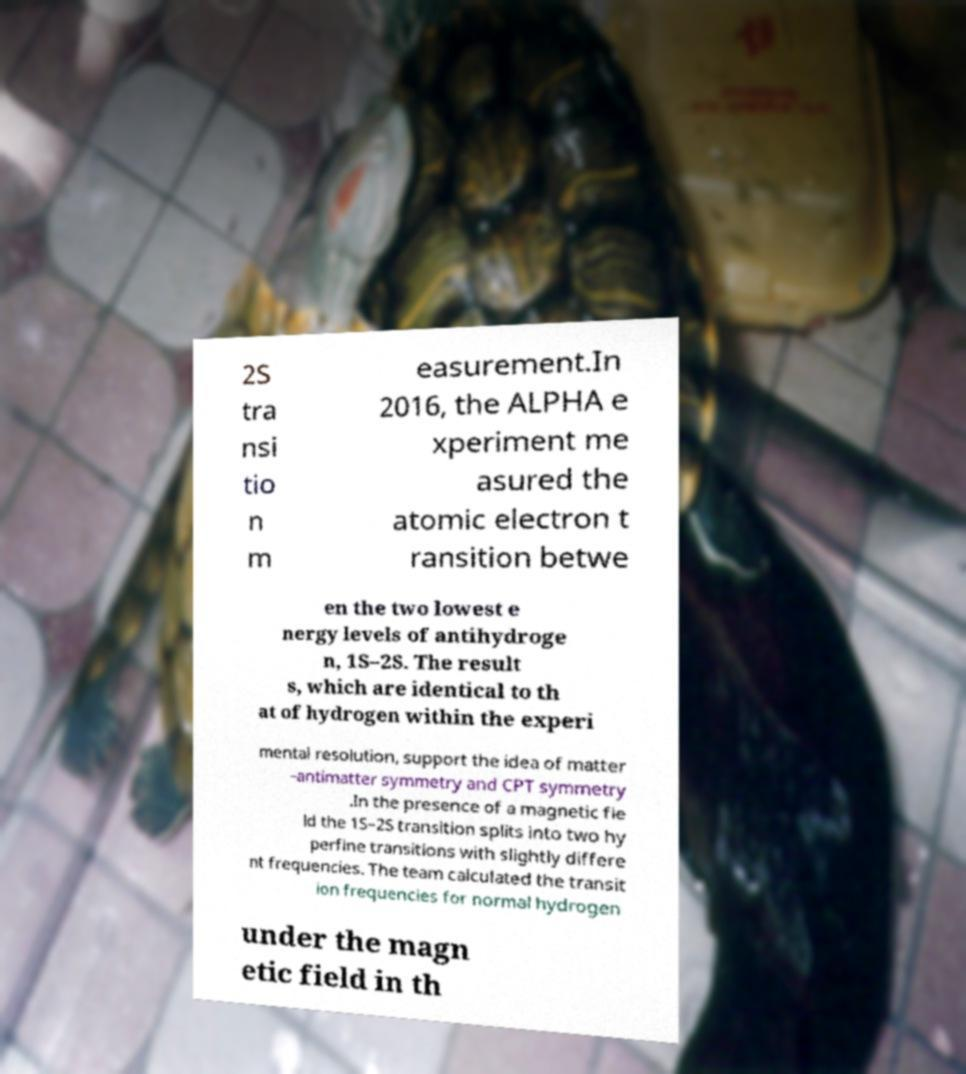There's text embedded in this image that I need extracted. Can you transcribe it verbatim? 2S tra nsi tio n m easurement.In 2016, the ALPHA e xperiment me asured the atomic electron t ransition betwe en the two lowest e nergy levels of antihydroge n, 1S–2S. The result s, which are identical to th at of hydrogen within the experi mental resolution, support the idea of matter –antimatter symmetry and CPT symmetry .In the presence of a magnetic fie ld the 1S–2S transition splits into two hy perfine transitions with slightly differe nt frequencies. The team calculated the transit ion frequencies for normal hydrogen under the magn etic field in th 